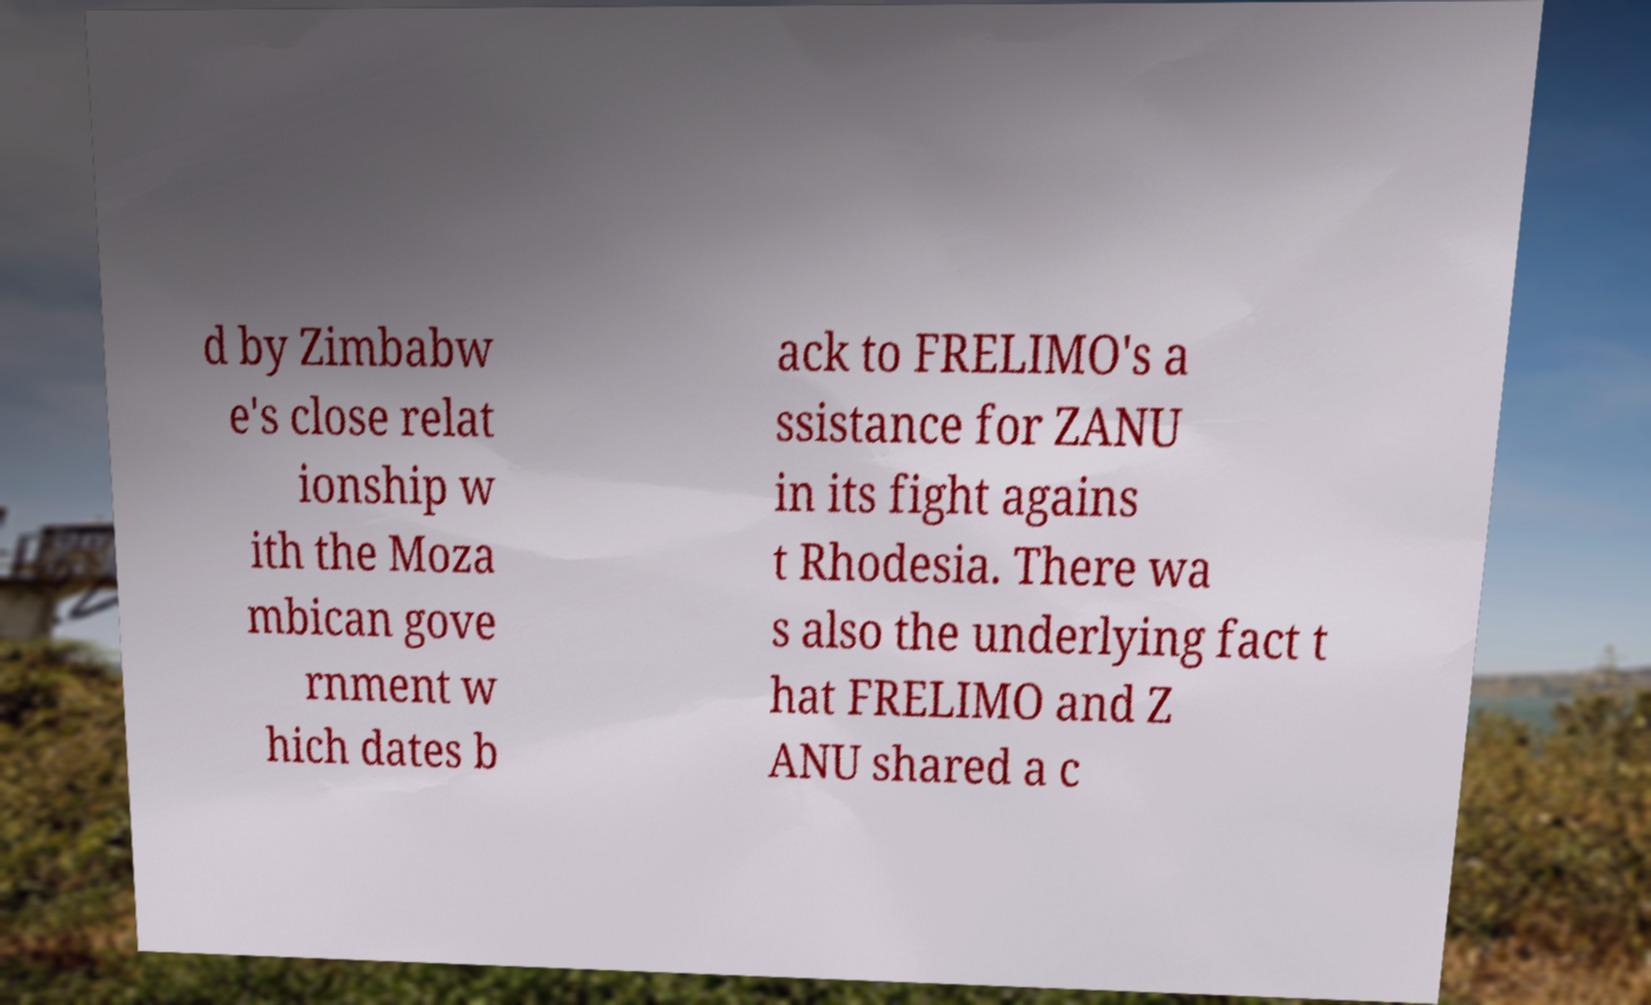Please read and relay the text visible in this image. What does it say? d by Zimbabw e's close relat ionship w ith the Moza mbican gove rnment w hich dates b ack to FRELIMO's a ssistance for ZANU in its fight agains t Rhodesia. There wa s also the underlying fact t hat FRELIMO and Z ANU shared a c 